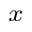<formula> <loc_0><loc_0><loc_500><loc_500>_ { x }</formula> 